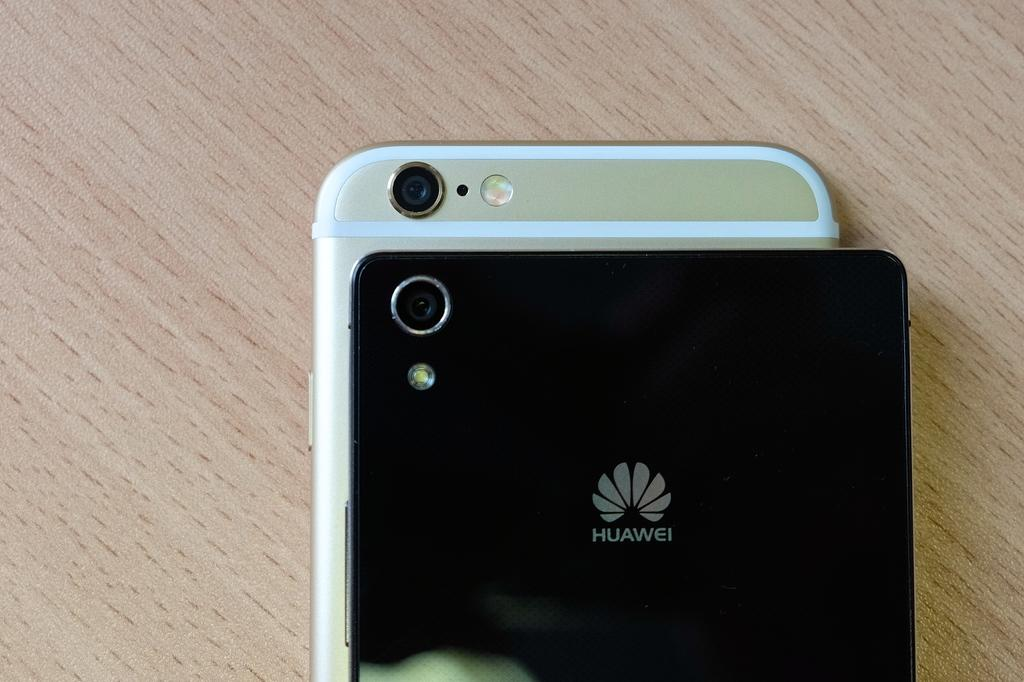<image>
Summarize the visual content of the image. The reverse side of two Huawei phones, one black, the other white. 